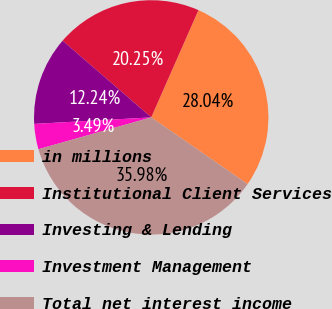Convert chart. <chart><loc_0><loc_0><loc_500><loc_500><pie_chart><fcel>in millions<fcel>Institutional Client Services<fcel>Investing & Lending<fcel>Investment Management<fcel>Total net interest income<nl><fcel>28.04%<fcel>20.25%<fcel>12.24%<fcel>3.49%<fcel>35.98%<nl></chart> 